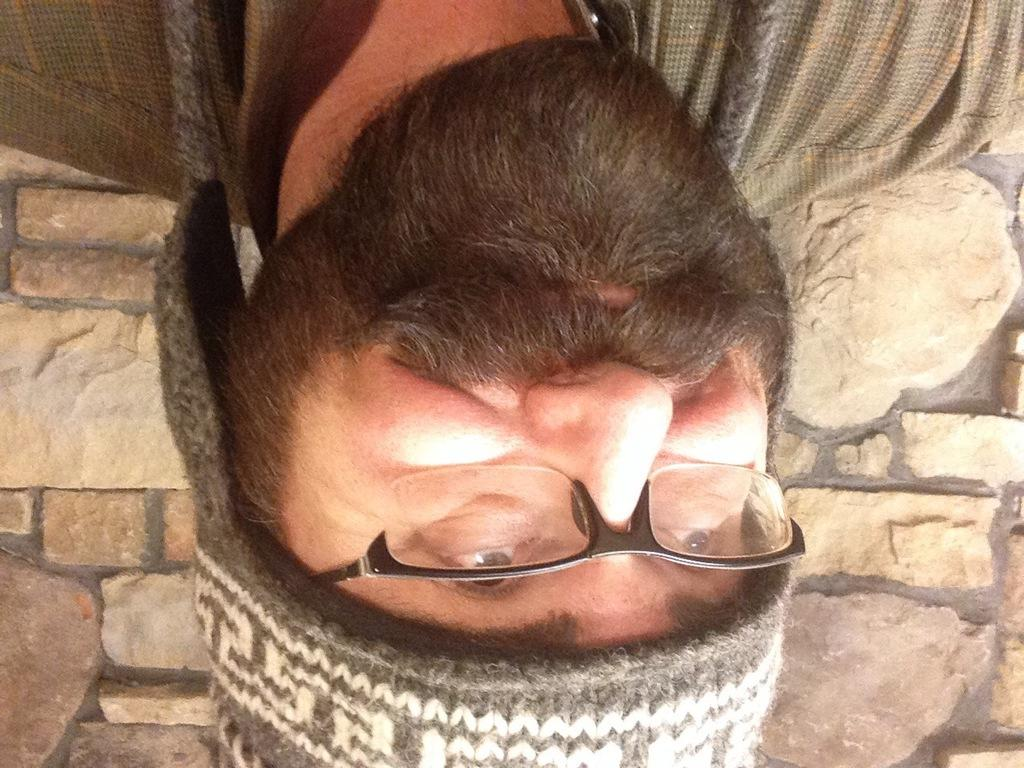What is the main subject in the foreground of the image? There is a man's face in the foreground of the image. How is the man's face positioned in the image? The man's face is upside down in the image. What can be seen in the background of the image? There is a wall in the background of the image. What type of process is the man's face undergoing in the image? There is no indication of a process occurring to the man's face in the image. Can you tell me how many friends are visible in the image? There are no friends visible in the image; it only features the man's face. 